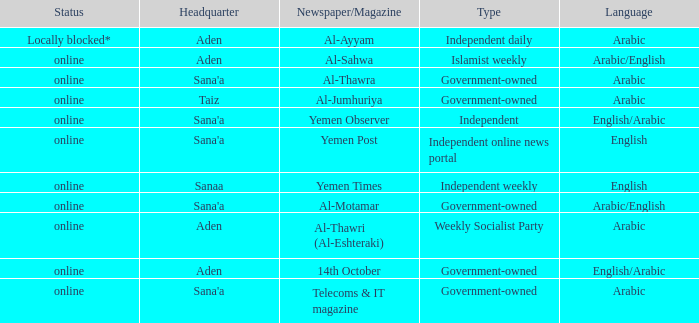What is Headquarter, when Newspaper/Magazine is Al-Ayyam? Aden. 